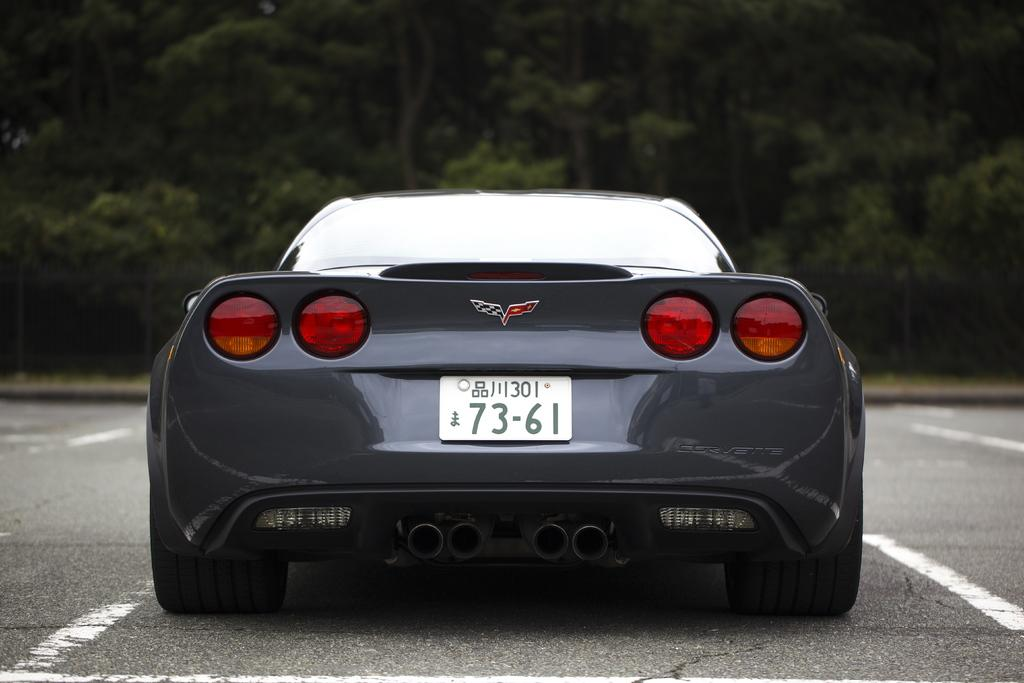Provide a one-sentence caption for the provided image. the back side of a black sports car with license plate 73-61. 